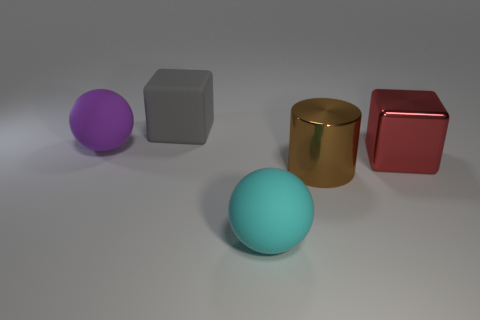Subtract all green spheres. Subtract all purple cubes. How many spheres are left? 2 Add 3 large red balls. How many objects exist? 8 Subtract all balls. How many objects are left? 3 Subtract 0 blue cylinders. How many objects are left? 5 Subtract all large red things. Subtract all big brown cylinders. How many objects are left? 3 Add 1 balls. How many balls are left? 3 Add 5 large cylinders. How many large cylinders exist? 6 